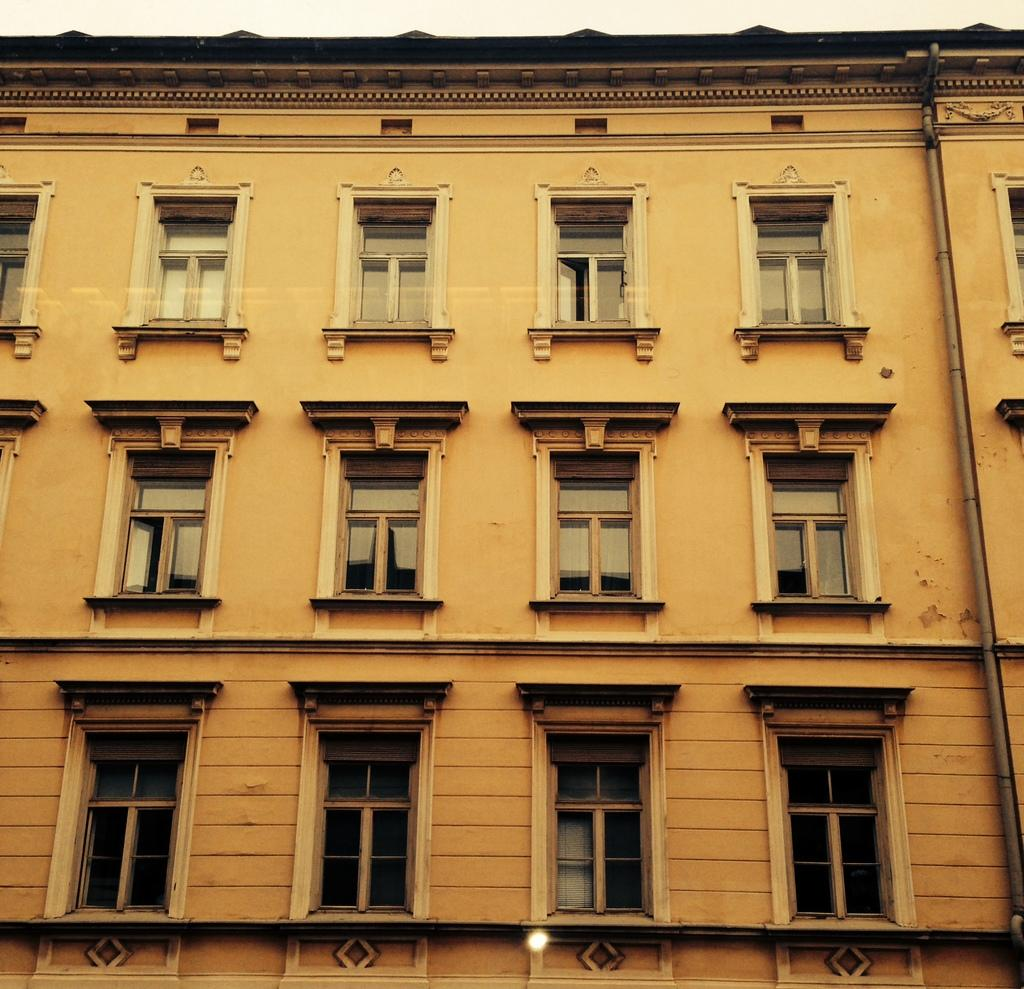What is the main subject of the image? The main subject of the image is a building. What specific feature can be observed on the building? The building has a group of windows. What can be seen in the background of the image? The sky is visible in the background of the image. What type of seed is being planted by the dad in the image? There is no dad or seed present in the image; it only features a building with a group of windows and the sky in the background. 